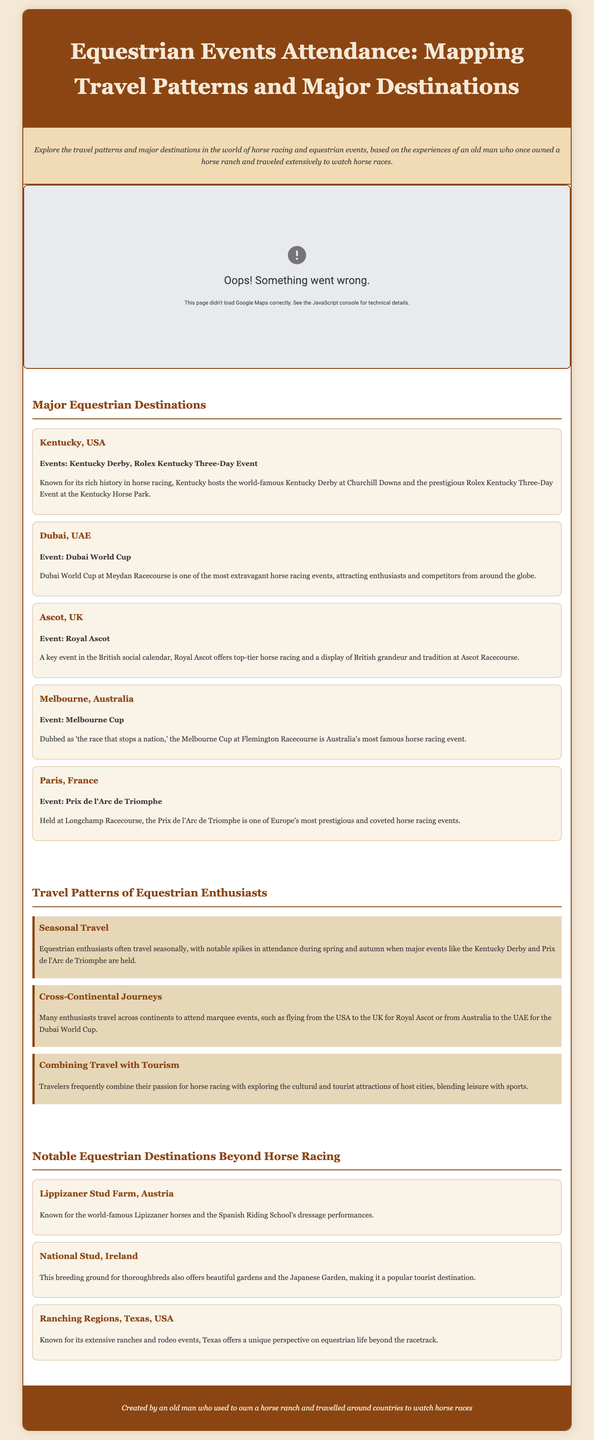What is the major event held in Kentucky? The major event held in Kentucky is the Kentucky Derby.
Answer: Kentucky Derby Which city hosts the Dubai World Cup? The Dubai World Cup is hosted in Dubai.
Answer: Dubai What is the name of the famous horse racing event in Melbourne? The famous horse racing event in Melbourne is the Melbourne Cup.
Answer: Melbourne Cup How many notable equestrian destinations are mentioned in the document? There are five notable equestrian destinations mentioned in the document.
Answer: Five What type of travel pattern do equestrian enthusiasts show during spring and autumn? Equestrian enthusiasts often travel seasonally during spring and autumn.
Answer: Seasonal travel Which country is known for the Royal Ascot event? The country known for the Royal Ascot event is the United Kingdom.
Answer: United Kingdom What type of horse performance is showcased at the Lippizaner Stud Farm? The Lippizaner Stud Farm showcases dressage performances.
Answer: Dressage performances What do many equestrian enthusiasts combine travel with according to the document? Many equestrian enthusiasts combine travel with tourism.
Answer: Tourism Where is the National Stud located? The National Stud is located in Ireland.
Answer: Ireland 